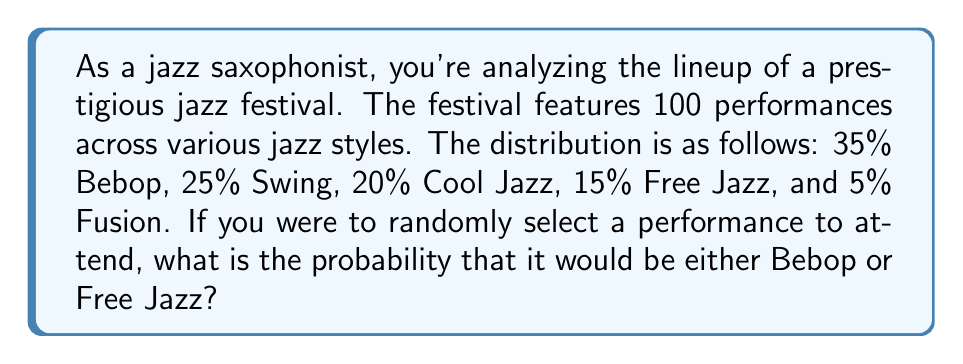Can you answer this question? To solve this problem, we'll follow these steps:

1. Identify the relevant jazz styles: Bebop and Free Jazz
2. Calculate the probabilities for each style:
   - Bebop: 35% = 0.35
   - Free Jazz: 15% = 0.15
3. Add the probabilities together, as we want the probability of either style

Let's calculate:

$$P(\text{Bebop or Free Jazz}) = P(\text{Bebop}) + P(\text{Free Jazz})$$
$$P(\text{Bebop or Free Jazz}) = 0.35 + 0.15$$
$$P(\text{Bebop or Free Jazz}) = 0.50$$

Therefore, the probability of randomly selecting either a Bebop or Free Jazz performance is 0.50 or 50%.
Answer: 0.50 